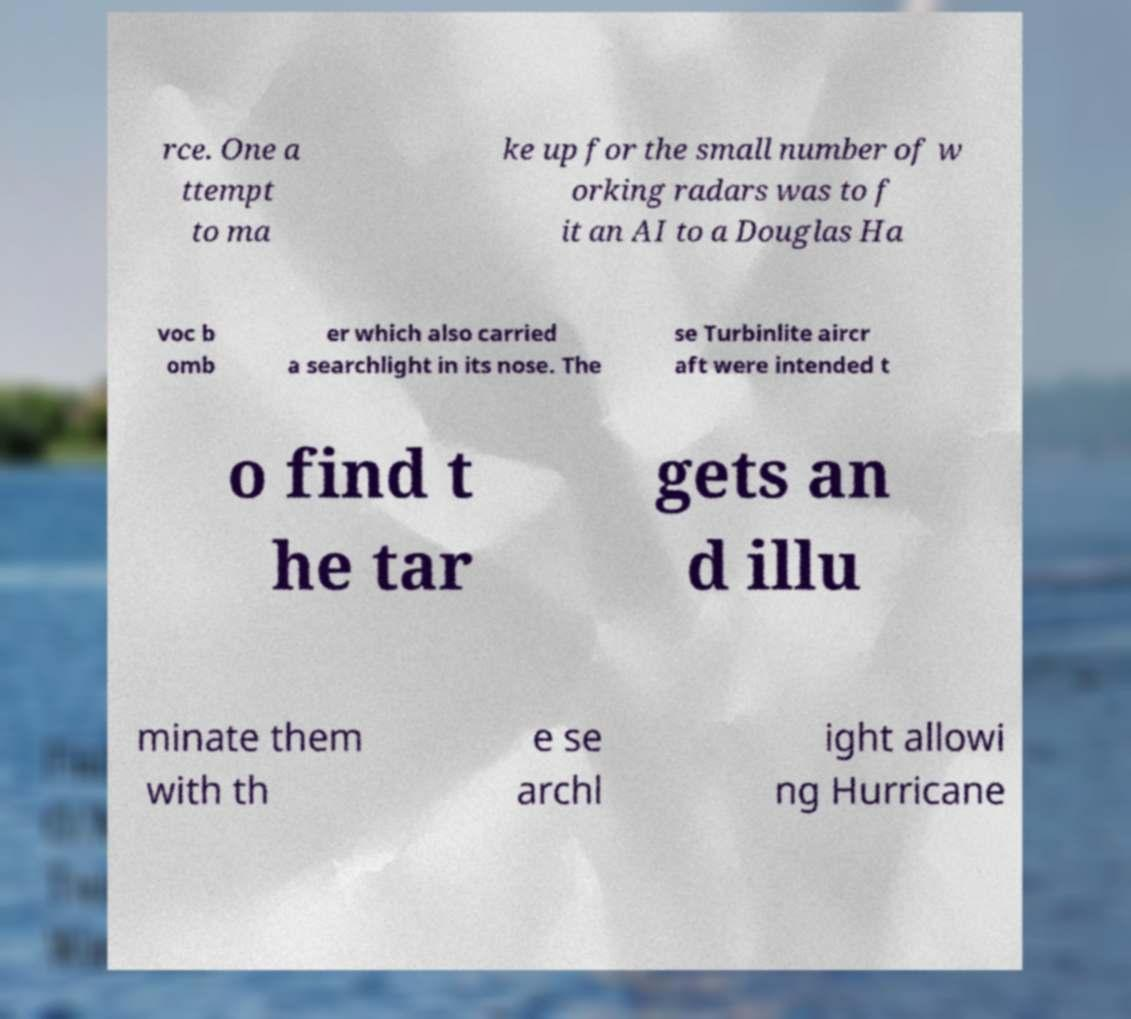Please read and relay the text visible in this image. What does it say? rce. One a ttempt to ma ke up for the small number of w orking radars was to f it an AI to a Douglas Ha voc b omb er which also carried a searchlight in its nose. The se Turbinlite aircr aft were intended t o find t he tar gets an d illu minate them with th e se archl ight allowi ng Hurricane 